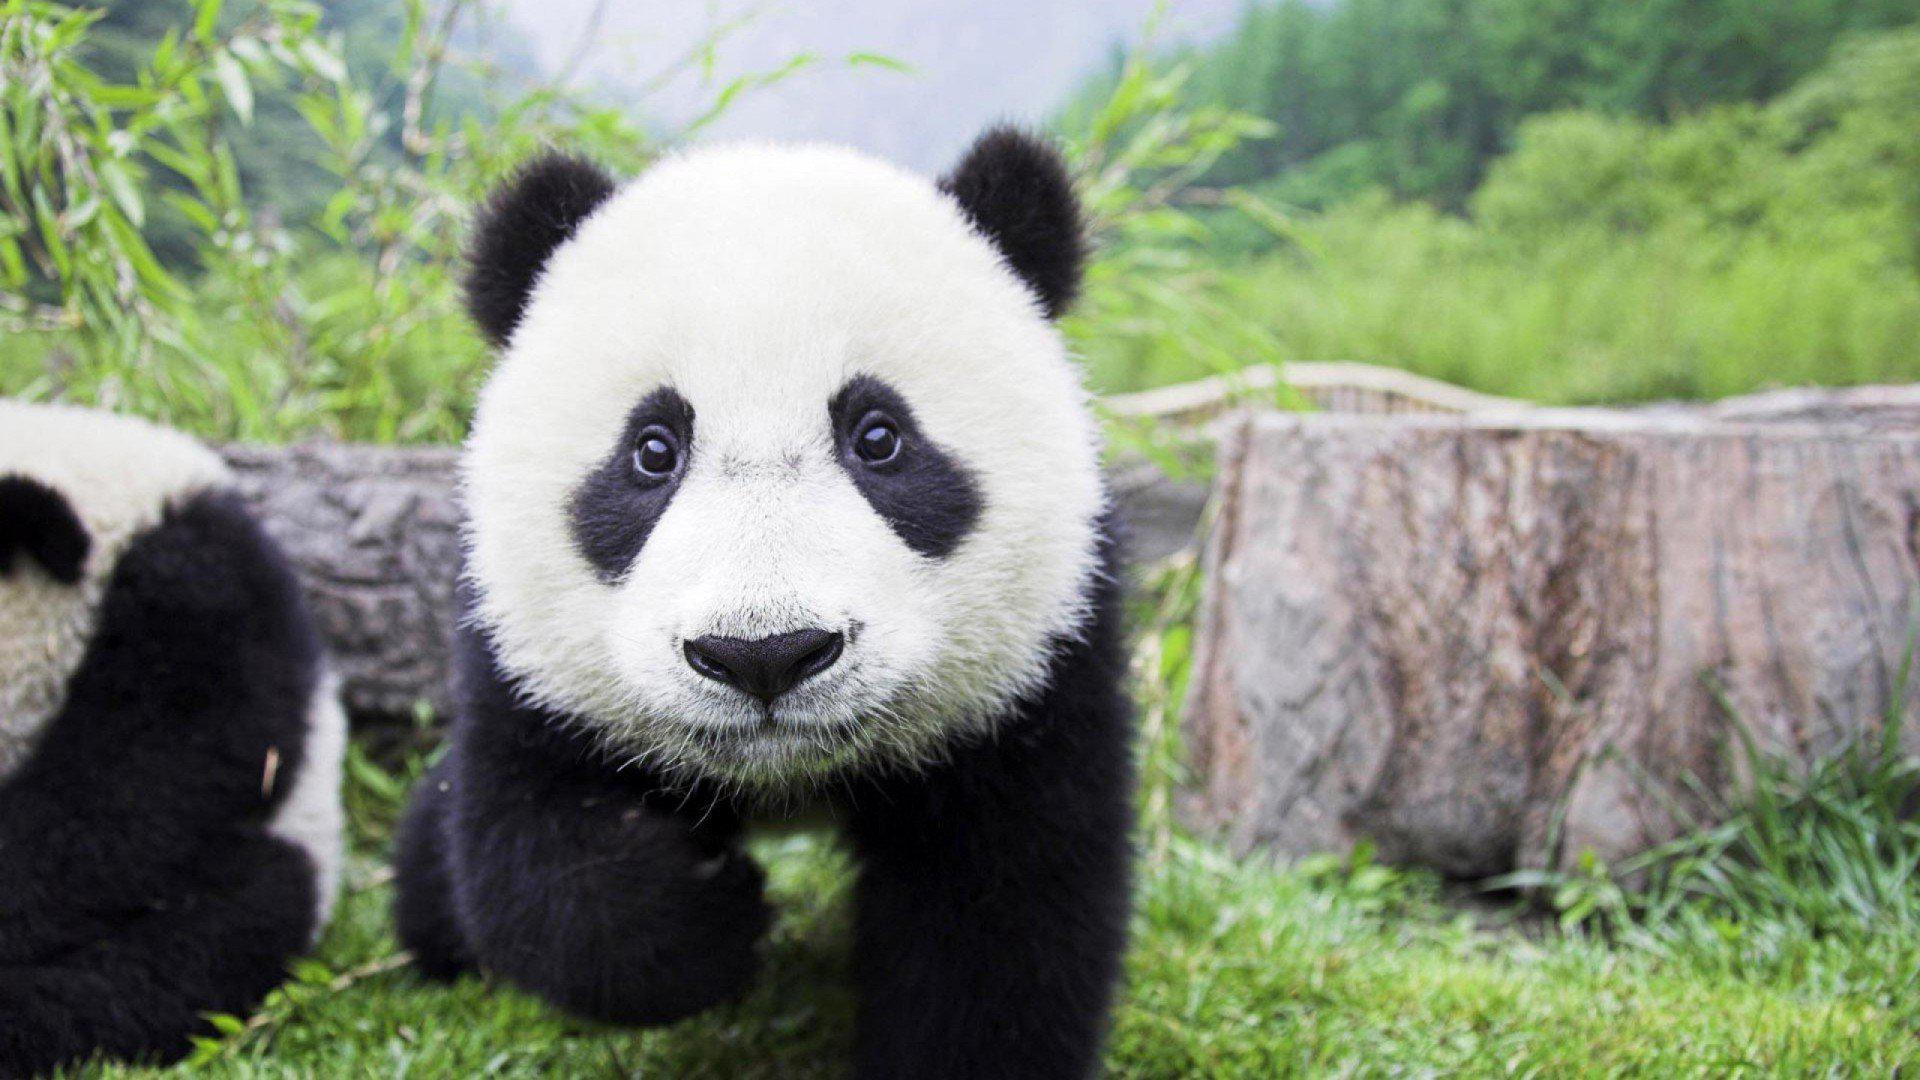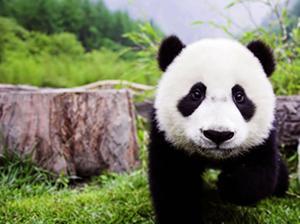The first image is the image on the left, the second image is the image on the right. For the images shown, is this caption "In one image, a panda is lying back with its mouth open and tongue showing." true? Answer yes or no. No. The first image is the image on the left, the second image is the image on the right. Analyze the images presented: Is the assertion "At least one of the pandas is lying down." valid? Answer yes or no. No. 